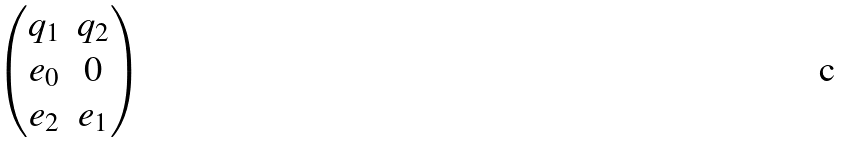<formula> <loc_0><loc_0><loc_500><loc_500>\begin{pmatrix} q _ { 1 } & q _ { 2 } \\ e _ { 0 } & 0 \\ e _ { 2 } & e _ { 1 } \\ \end{pmatrix}</formula> 